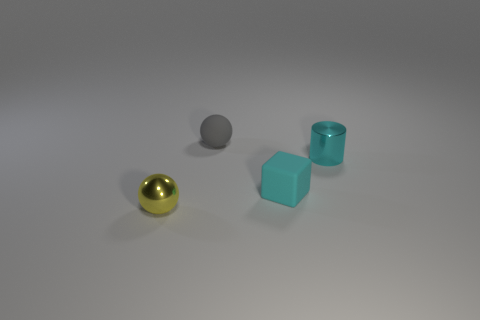Subtract all purple balls. Subtract all brown cubes. How many balls are left? 2 Add 4 tiny brown shiny cubes. How many objects exist? 8 Subtract all blocks. How many objects are left? 3 Add 1 yellow metal things. How many yellow metal things are left? 2 Add 2 large brown matte things. How many large brown matte things exist? 2 Subtract 0 yellow cylinders. How many objects are left? 4 Subtract all balls. Subtract all tiny red spheres. How many objects are left? 2 